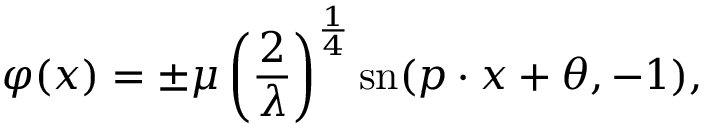<formula> <loc_0><loc_0><loc_500><loc_500>\varphi ( x ) = \pm \mu \left ( { \frac { 2 } { \lambda } } \right ) ^ { \frac { 1 } { 4 } } { s n } ( p \cdot x + \theta , - 1 ) ,</formula> 